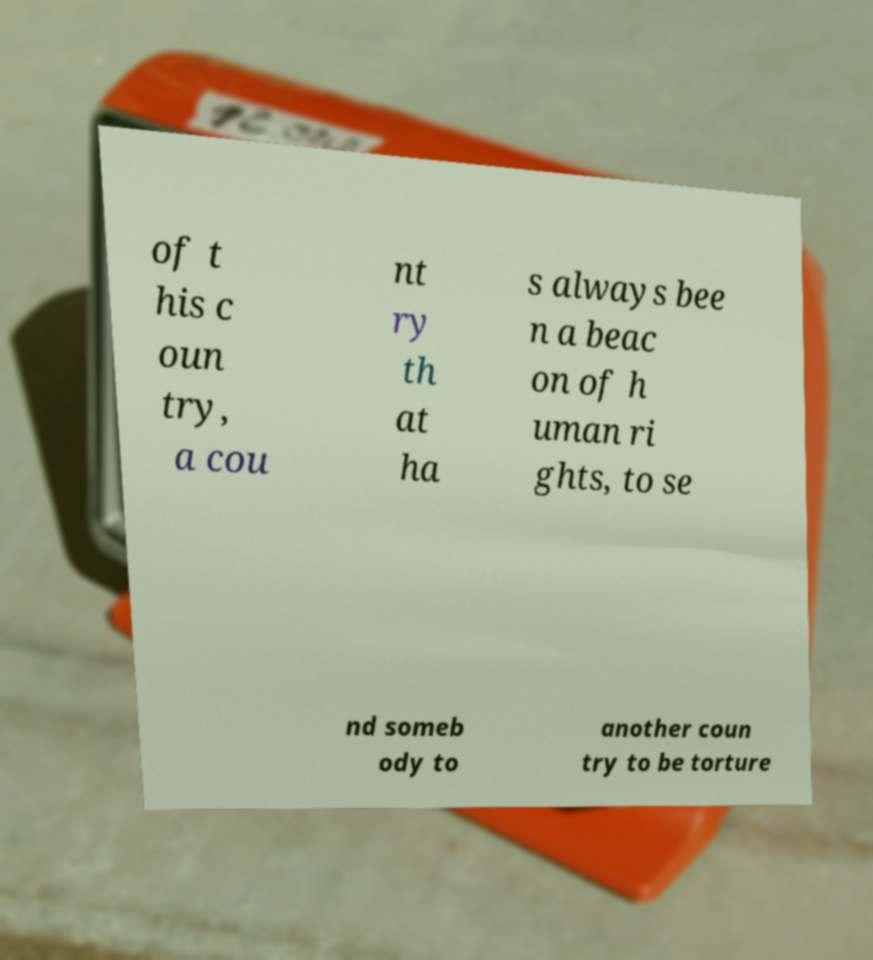Could you assist in decoding the text presented in this image and type it out clearly? of t his c oun try, a cou nt ry th at ha s always bee n a beac on of h uman ri ghts, to se nd someb ody to another coun try to be torture 